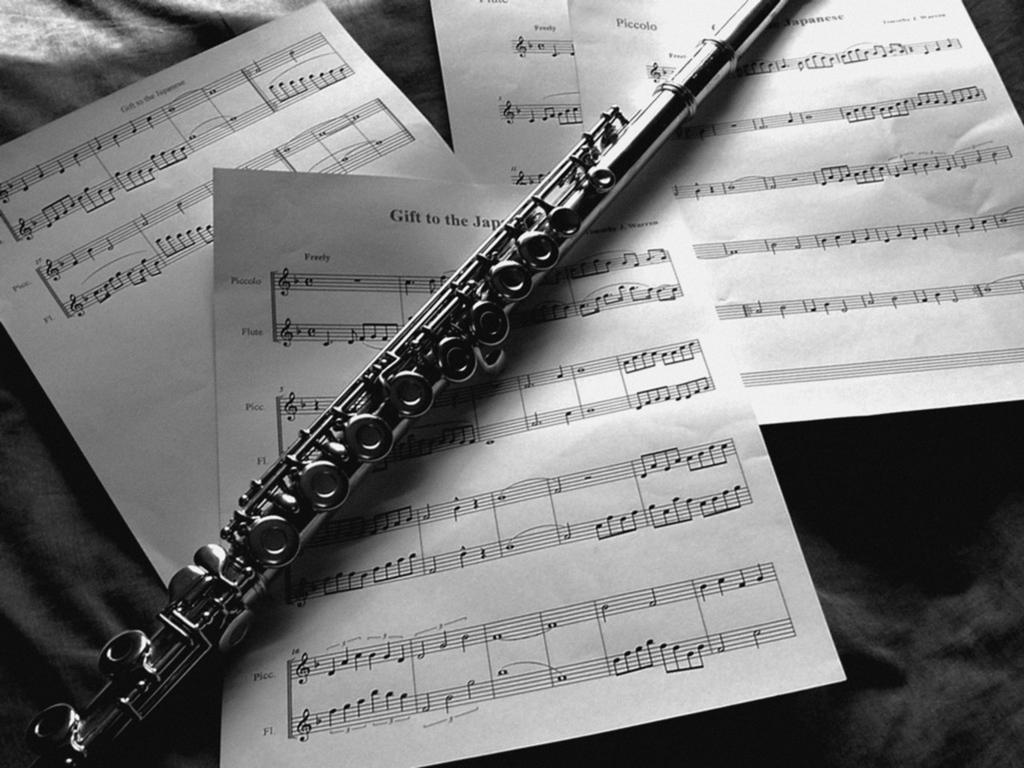Can you describe this image briefly? Here in this picture we can see a flute and some papers with musical notes, all present on a table. 